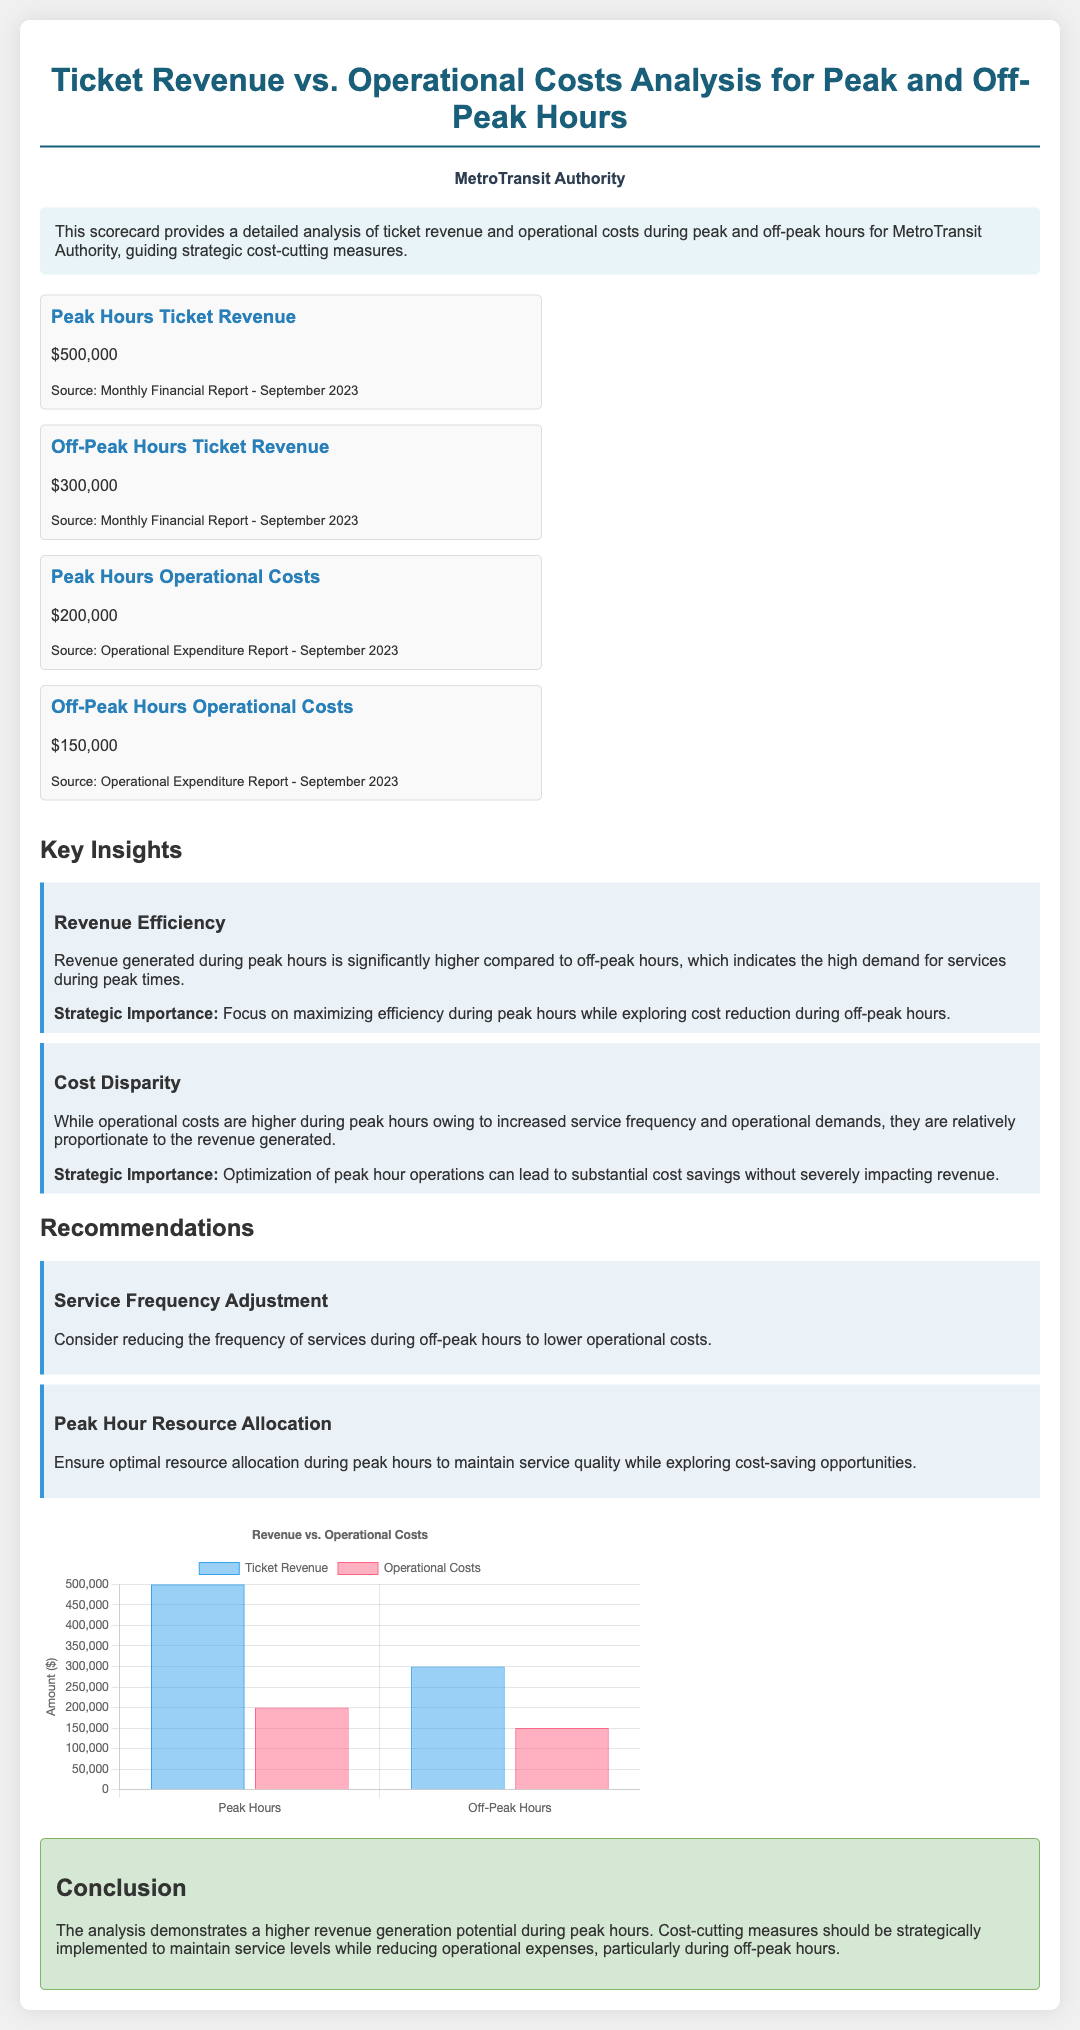what is the peak hours ticket revenue? The document states that the peak hours ticket revenue is indicated as $500,000.
Answer: $500,000 what are the off-peak hours operational costs? According to the scorecard, off-peak hours operational costs are listed as $150,000.
Answer: $150,000 what is the total operational costs during peak hours? The peak hours operational costs are specifically mentioned as $200,000 in the document.
Answer: $200,000 which period has higher ticket revenue? The scorecard shows that peak hours ticket revenue is significantly higher than off-peak hours ticket revenue.
Answer: Peak hours what is one recommendation made in the scorecard? The scorecard suggests considering a reduction in service frequency during off-peak hours to lower operational costs.
Answer: Service frequency adjustment how much is the off-peak hours ticket revenue? The document specifies the off-peak hours ticket revenue as $300,000.
Answer: $300,000 what is the conclusion about revenue generation potential? The conclusion states that higher revenue generation potential exists during peak hours compared to off-peak hours.
Answer: Higher during peak hours what is the cost disparity mentioned in the insights? It mentions that operational costs during peak hours are higher but proportionate to revenue; this indicates a cost disparity.
Answer: Cost disparity how much is the peak hours operational costs? The document lists the peak hours operational costs as $200,000.
Answer: $200,000 